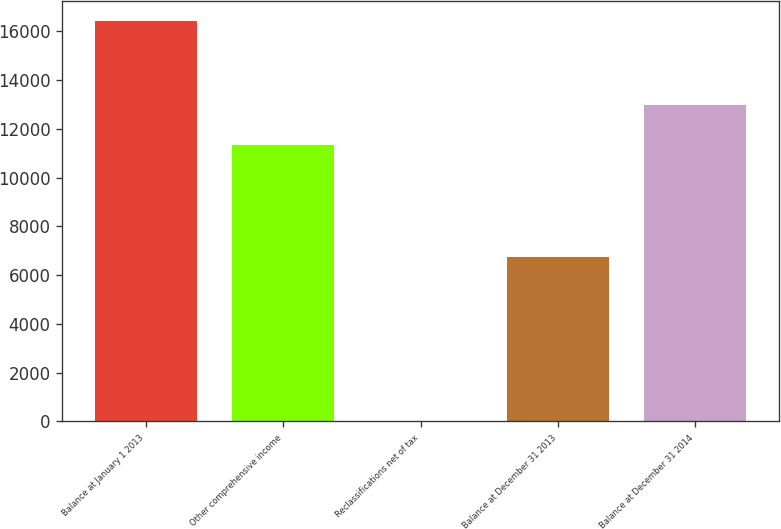Convert chart to OTSL. <chart><loc_0><loc_0><loc_500><loc_500><bar_chart><fcel>Balance at January 1 2013<fcel>Other comprehensive income<fcel>Reclassifications net of tax<fcel>Balance at December 31 2013<fcel>Balance at December 31 2014<nl><fcel>16417<fcel>11330.7<fcel>0.12<fcel>6728<fcel>12972.4<nl></chart> 